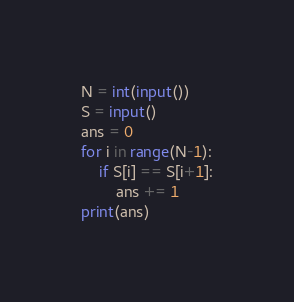Convert code to text. <code><loc_0><loc_0><loc_500><loc_500><_Python_>N = int(input())
S = input()
ans = 0
for i in range(N-1):
    if S[i] == S[i+1]:
        ans += 1
print(ans)</code> 